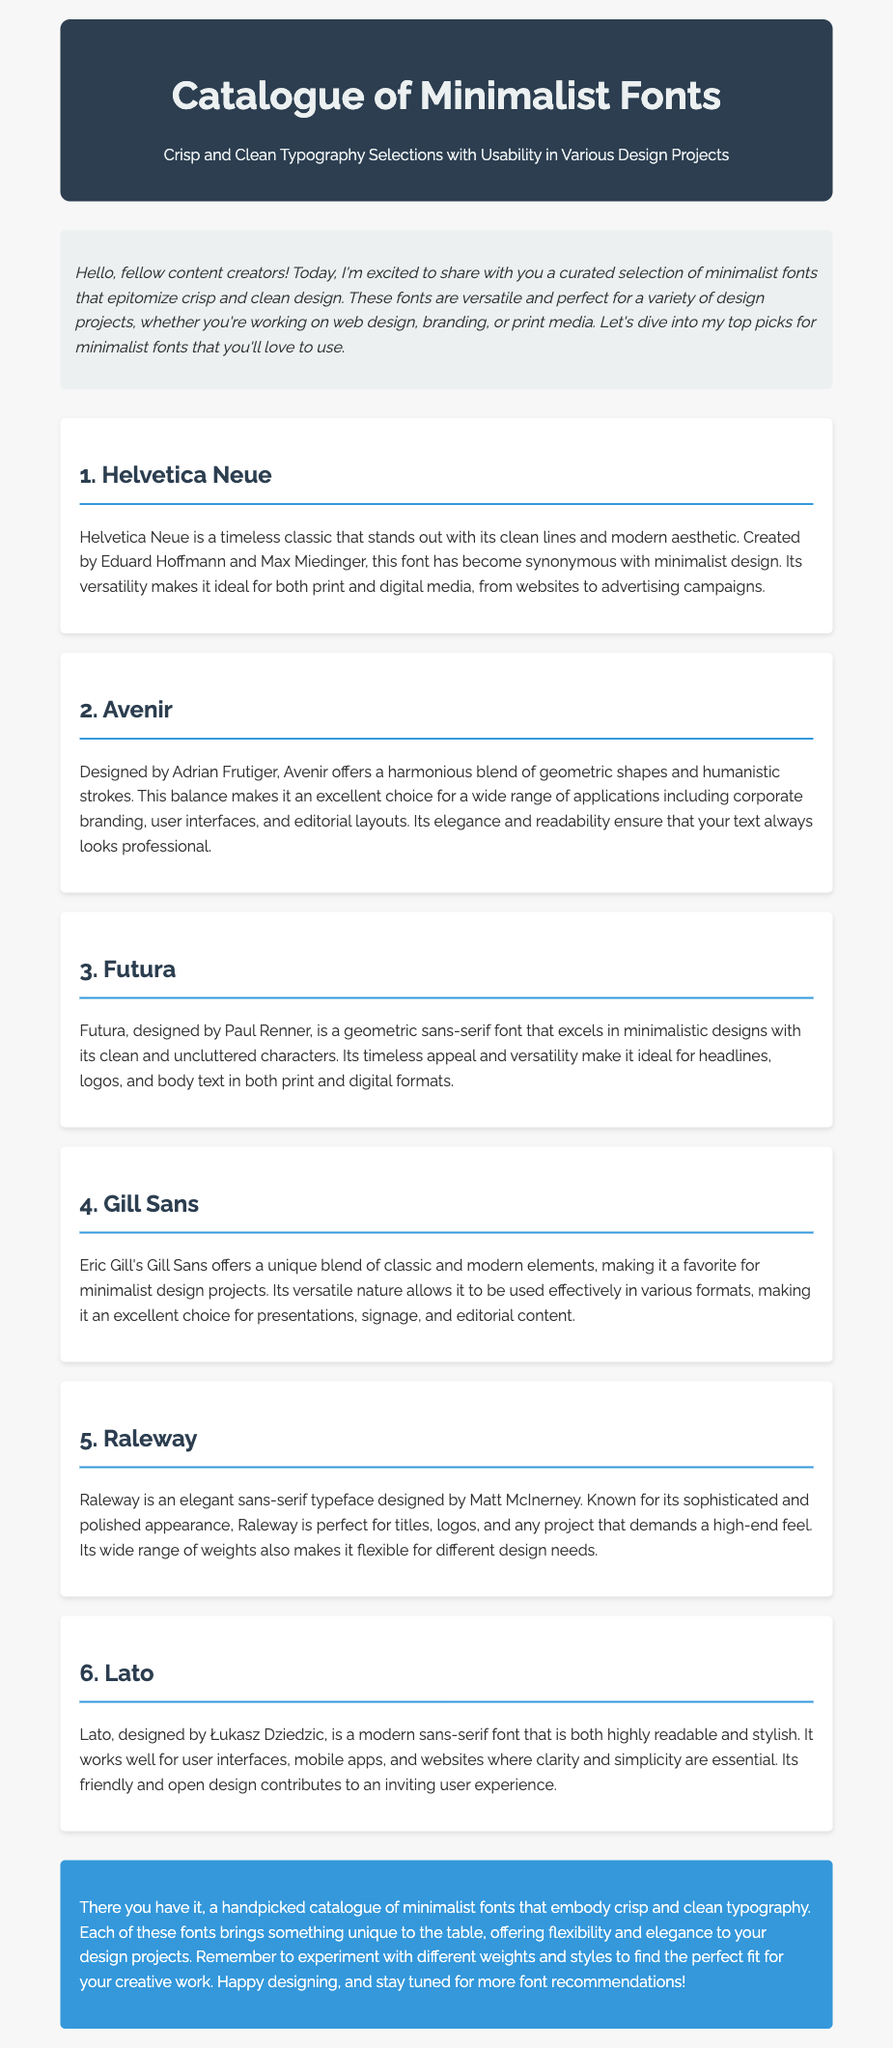What is the title of the document? The title is presented in the header section of the document.
Answer: Catalogue of Minimalist Fonts Who designed the font Avenir? The document credits Adrian Frutiger as the designer of Avenir.
Answer: Adrian Frutiger What is the theme of the document? The document focuses on a specific aspect of typography, signified in the introduction.
Answer: Minimalist fonts How many fonts are listed in the document? The number of fonts can be counted from the individual sections provided.
Answer: Six Which font is known for its modern aesthetic? The document describes Helvetica Neue as having a modern aesthetic.
Answer: Helvetica Neue What is the conclusion's background color? The background color of the conclusion is mentioned in the style section, as well as visually identifiable in the document.
Answer: Blue What type of content is the document designed for? The introduction states the purpose of the document and its intended audience.
Answer: Design projects What is a characteristic of the font Lato? The document highlights Lato's readability and stylish design.
Answer: Highly readable 